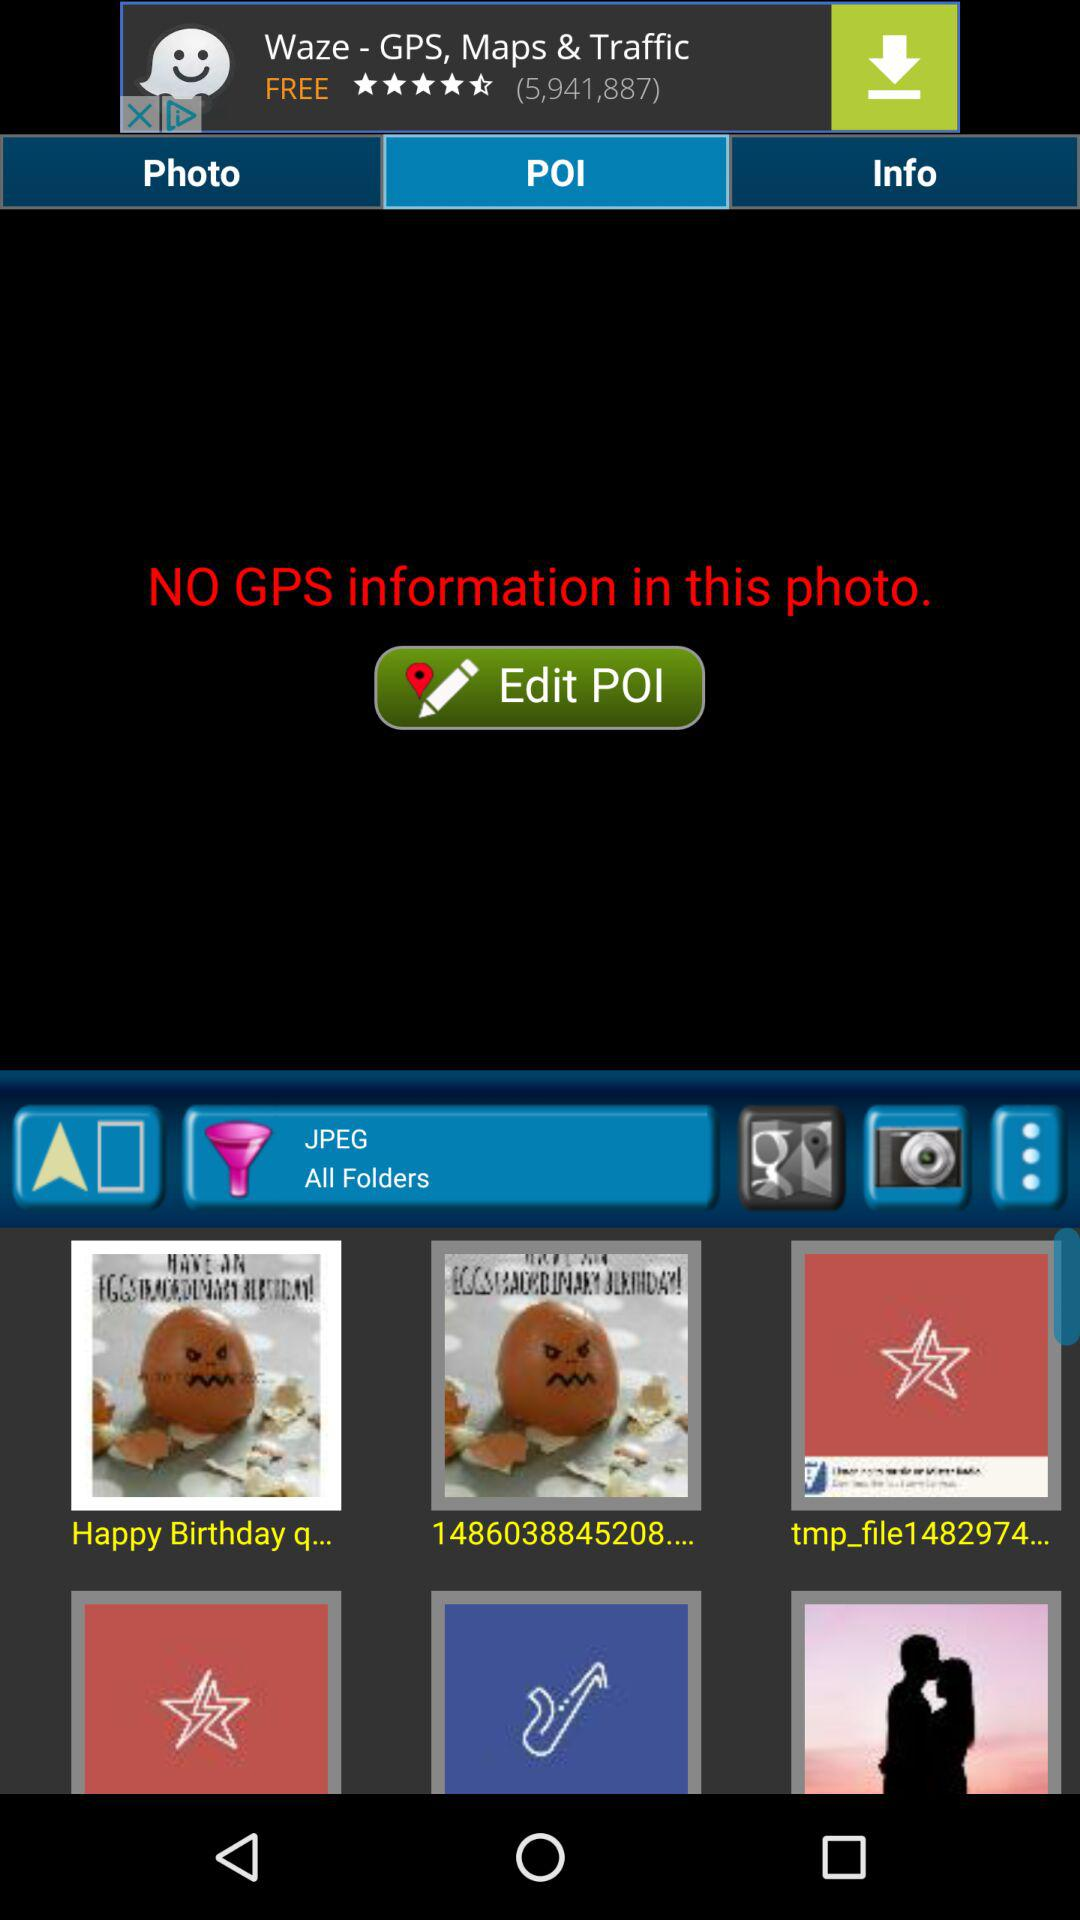What is the selected library? The selected library is "POI". 